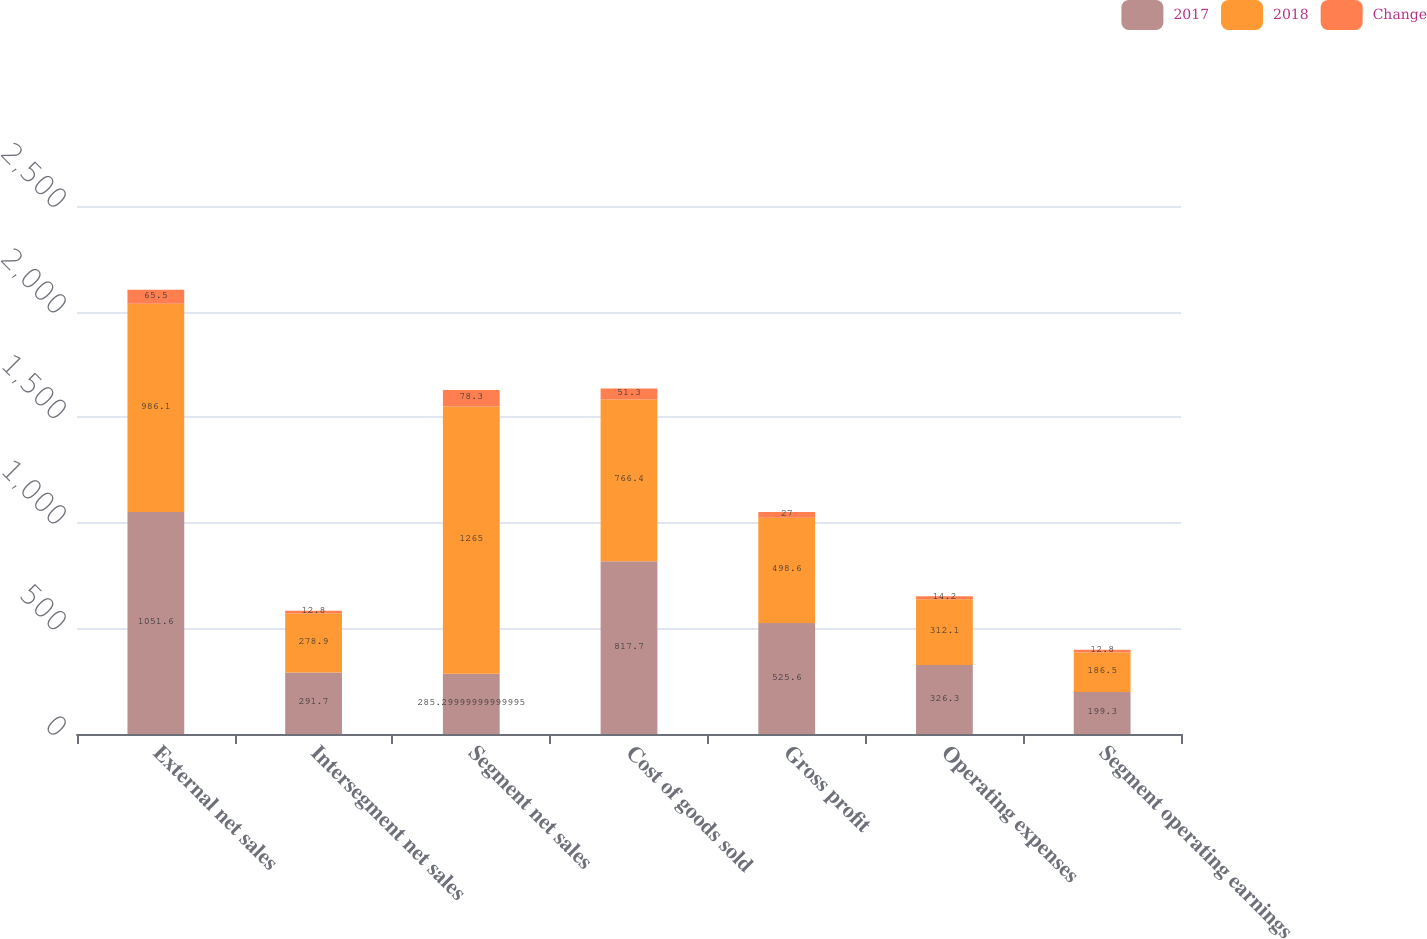<chart> <loc_0><loc_0><loc_500><loc_500><stacked_bar_chart><ecel><fcel>External net sales<fcel>Intersegment net sales<fcel>Segment net sales<fcel>Cost of goods sold<fcel>Gross profit<fcel>Operating expenses<fcel>Segment operating earnings<nl><fcel>2017<fcel>1051.6<fcel>291.7<fcel>285.3<fcel>817.7<fcel>525.6<fcel>326.3<fcel>199.3<nl><fcel>2018<fcel>986.1<fcel>278.9<fcel>1265<fcel>766.4<fcel>498.6<fcel>312.1<fcel>186.5<nl><fcel>Change<fcel>65.5<fcel>12.8<fcel>78.3<fcel>51.3<fcel>27<fcel>14.2<fcel>12.8<nl></chart> 